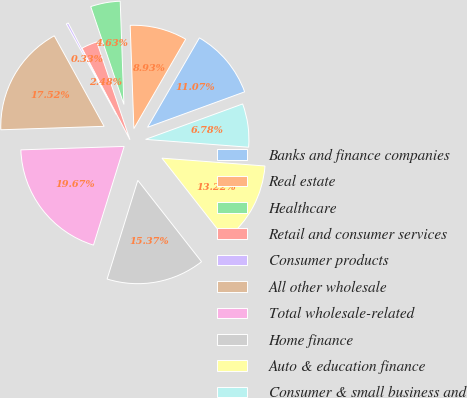Convert chart. <chart><loc_0><loc_0><loc_500><loc_500><pie_chart><fcel>Banks and finance companies<fcel>Real estate<fcel>Healthcare<fcel>Retail and consumer services<fcel>Consumer products<fcel>All other wholesale<fcel>Total wholesale-related<fcel>Home finance<fcel>Auto & education finance<fcel>Consumer & small business and<nl><fcel>11.07%<fcel>8.93%<fcel>4.63%<fcel>2.48%<fcel>0.33%<fcel>17.52%<fcel>19.67%<fcel>15.37%<fcel>13.22%<fcel>6.78%<nl></chart> 